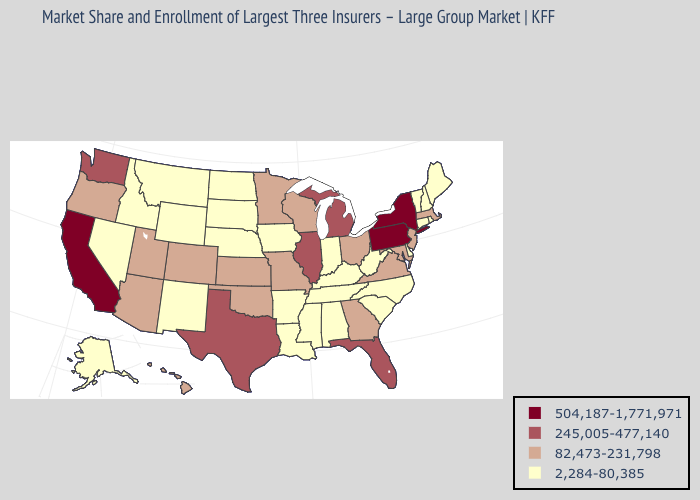What is the lowest value in the MidWest?
Concise answer only. 2,284-80,385. What is the value of Georgia?
Quick response, please. 82,473-231,798. Name the states that have a value in the range 245,005-477,140?
Answer briefly. Florida, Illinois, Michigan, Texas, Washington. What is the value of South Carolina?
Write a very short answer. 2,284-80,385. How many symbols are there in the legend?
Concise answer only. 4. Among the states that border Pennsylvania , which have the lowest value?
Answer briefly. Delaware, West Virginia. Does the map have missing data?
Keep it brief. No. Is the legend a continuous bar?
Keep it brief. No. Does New York have the lowest value in the Northeast?
Keep it brief. No. What is the value of Virginia?
Answer briefly. 82,473-231,798. How many symbols are there in the legend?
Answer briefly. 4. Name the states that have a value in the range 245,005-477,140?
Answer briefly. Florida, Illinois, Michigan, Texas, Washington. Which states have the lowest value in the USA?
Keep it brief. Alabama, Alaska, Arkansas, Connecticut, Delaware, Idaho, Indiana, Iowa, Kentucky, Louisiana, Maine, Mississippi, Montana, Nebraska, Nevada, New Hampshire, New Mexico, North Carolina, North Dakota, Rhode Island, South Carolina, South Dakota, Tennessee, Vermont, West Virginia, Wyoming. What is the highest value in the USA?
Short answer required. 504,187-1,771,971. Among the states that border Vermont , does Massachusetts have the lowest value?
Concise answer only. No. 